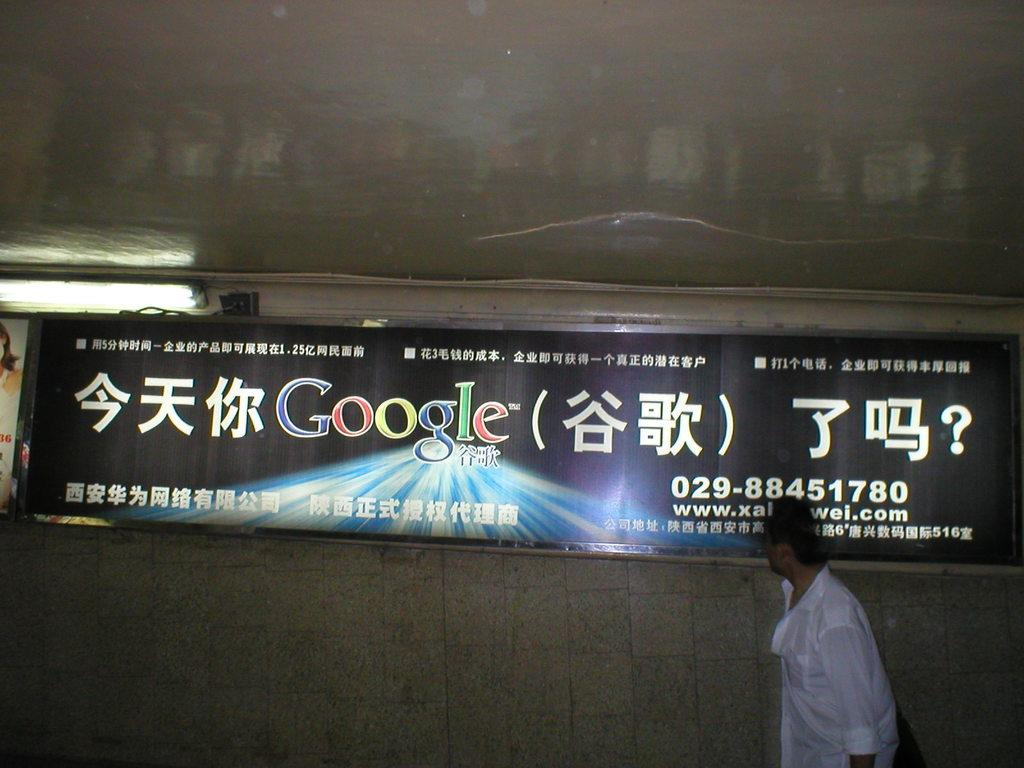Who is present in the image? There is a man in the image. What can be seen hanging in the image? There are banners in the image. What type of illumination is present in the image? There are lights in the image. What is visible in the background of the image? There is a wall in the background of the image. What type of jar is being used by the doctor in the image? There is no doctor or jar present in the image. Can you describe the garden in the image? There is no garden present in the image. 